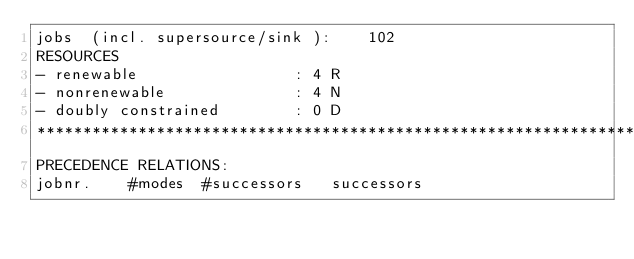Convert code to text. <code><loc_0><loc_0><loc_500><loc_500><_ObjectiveC_>jobs  (incl. supersource/sink ):	102
RESOURCES
- renewable                 : 4 R
- nonrenewable              : 4 N
- doubly constrained        : 0 D
************************************************************************
PRECEDENCE RELATIONS:
jobnr.    #modes  #successors   successors</code> 